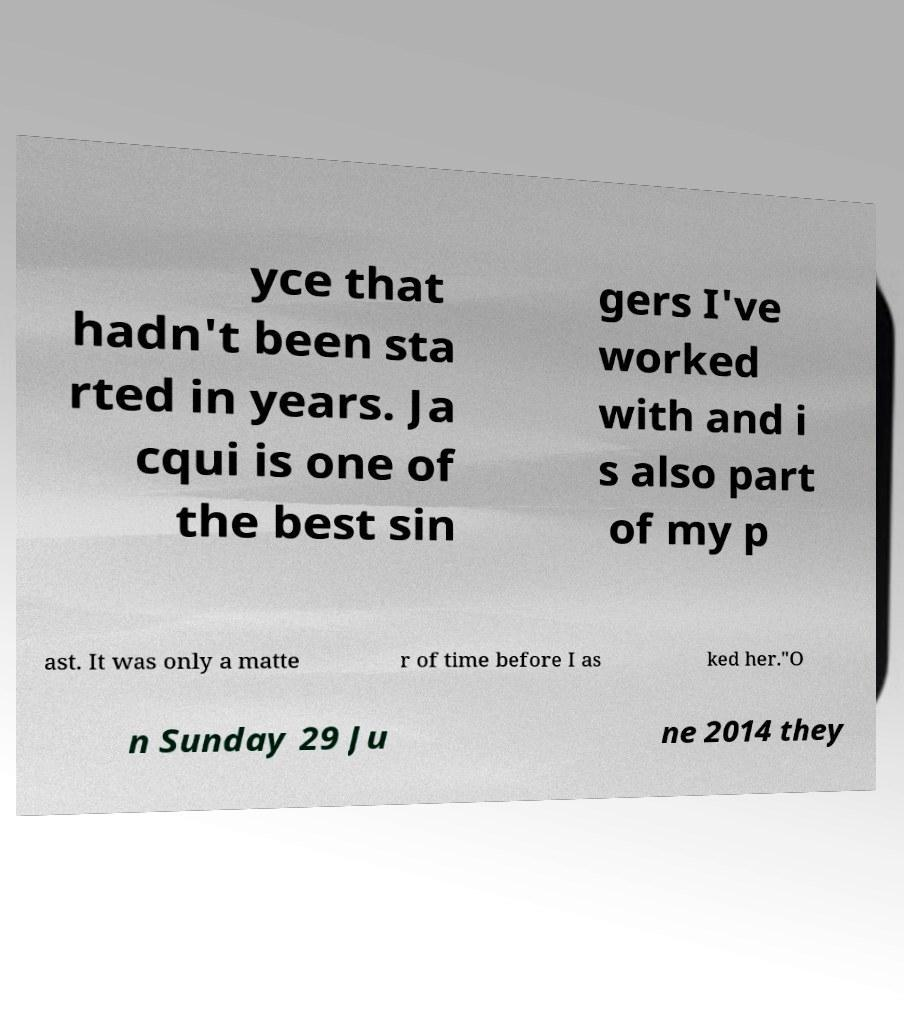What messages or text are displayed in this image? I need them in a readable, typed format. yce that hadn't been sta rted in years. Ja cqui is one of the best sin gers I've worked with and i s also part of my p ast. It was only a matte r of time before I as ked her."O n Sunday 29 Ju ne 2014 they 